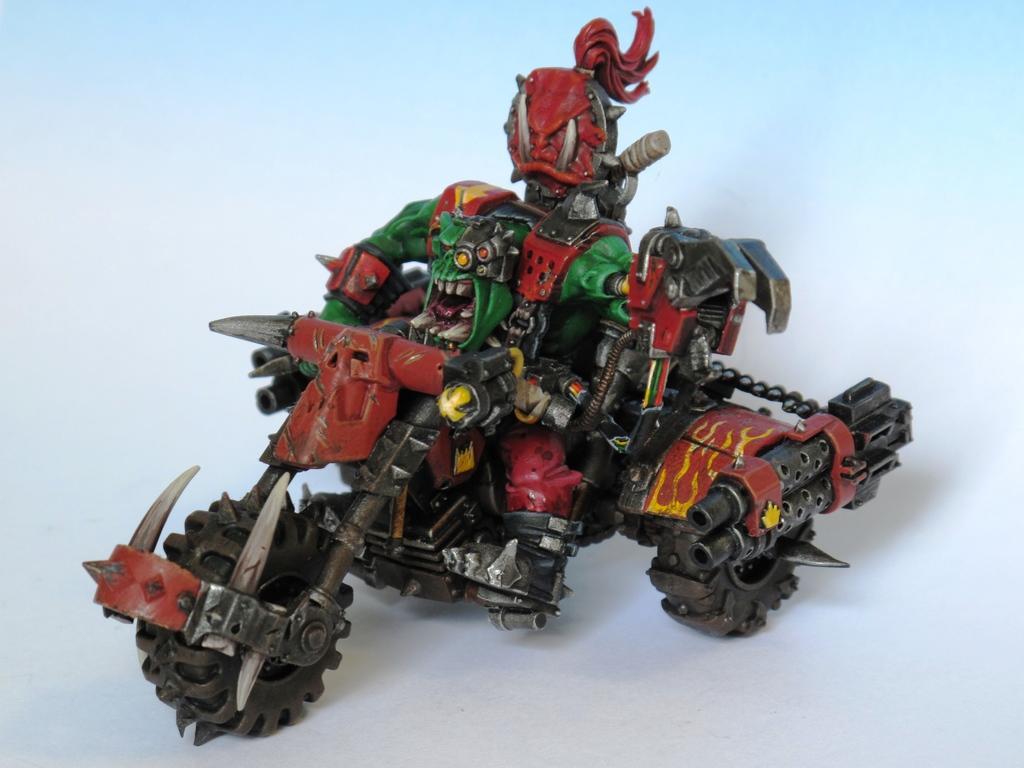Could you give a brief overview of what you see in this image? In this image we can see a toy tricycle placed on the surface. 